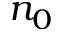<formula> <loc_0><loc_0><loc_500><loc_500>n _ { 0 }</formula> 